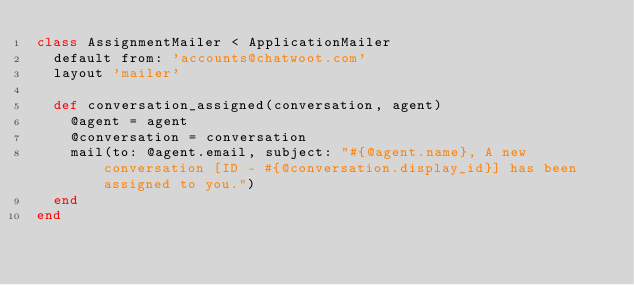<code> <loc_0><loc_0><loc_500><loc_500><_Ruby_>class AssignmentMailer < ApplicationMailer
  default from: 'accounts@chatwoot.com'
  layout 'mailer'

  def conversation_assigned(conversation, agent)
    @agent = agent
    @conversation = conversation
    mail(to: @agent.email, subject: "#{@agent.name}, A new conversation [ID - #{@conversation.display_id}] has been assigned to you.")
  end
end
</code> 